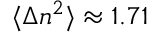<formula> <loc_0><loc_0><loc_500><loc_500>\langle \Delta n ^ { 2 } \rangle \approx 1 . 7 1</formula> 